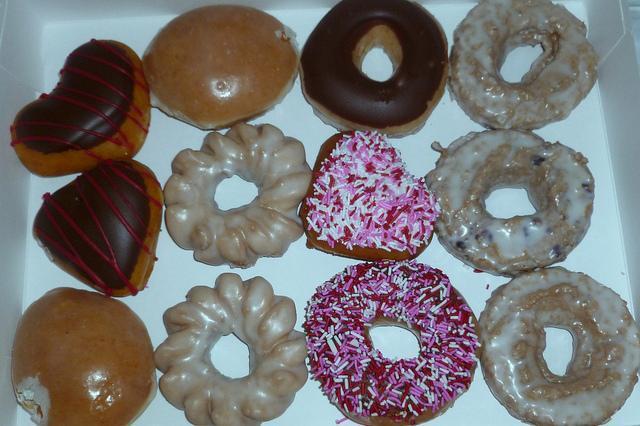How many doughnuts are there?
Give a very brief answer. 12. How many donuts can be seen?
Give a very brief answer. 12. How many zebras are there?
Give a very brief answer. 0. 